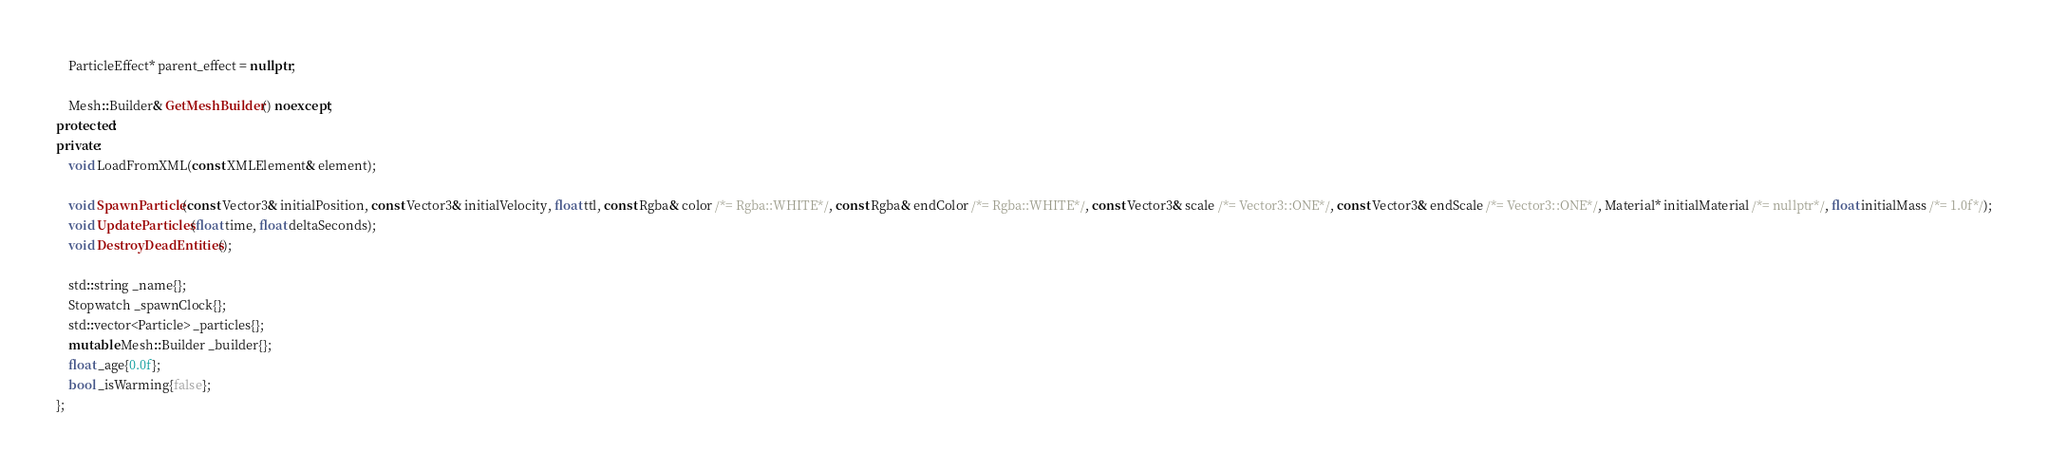<code> <loc_0><loc_0><loc_500><loc_500><_C++_>    ParticleEffect* parent_effect = nullptr;

    Mesh::Builder& GetMeshBuilder() noexcept;
protected:
private:
    void LoadFromXML(const XMLElement& element);

    void SpawnParticle(const Vector3& initialPosition, const Vector3& initialVelocity, float ttl, const Rgba& color /*= Rgba::WHITE*/, const Rgba& endColor /*= Rgba::WHITE*/, const Vector3& scale /*= Vector3::ONE*/, const Vector3& endScale /*= Vector3::ONE*/, Material* initialMaterial /*= nullptr*/, float initialMass /*= 1.0f*/);
    void UpdateParticles(float time, float deltaSeconds);
    void DestroyDeadEntities();

    std::string _name{};
    Stopwatch _spawnClock{};
    std::vector<Particle> _particles{};
    mutable Mesh::Builder _builder{};
    float _age{0.0f};
    bool _isWarming{false};
};
</code> 